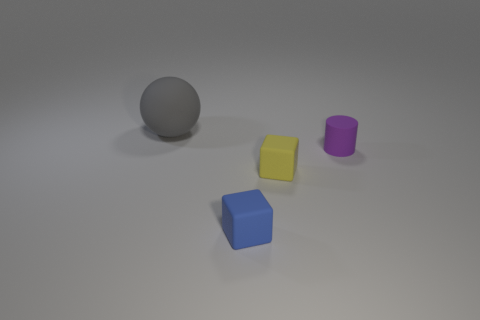What number of other things are there of the same size as the yellow block?
Ensure brevity in your answer.  2. How many things are either gray objects or purple objects?
Your response must be concise. 2. Is there anything else that is the same color as the large rubber sphere?
Keep it short and to the point. No. What is the shape of the tiny purple matte object that is right of the matte cube left of the yellow rubber object?
Your answer should be very brief. Cylinder. There is a thing that is behind the tiny yellow block and to the right of the small blue matte block; what shape is it?
Offer a very short reply. Cylinder. How many things are either tiny green metallic blocks or objects left of the tiny blue rubber thing?
Offer a terse response. 1. How many other small matte objects are the same shape as the yellow object?
Your answer should be compact. 1. There is a tiny thing right of the tiny cube right of the tiny blue rubber thing; what color is it?
Keep it short and to the point. Purple. Is the number of small purple rubber cylinders that are on the right side of the tiny purple matte cylinder the same as the number of cyan objects?
Offer a very short reply. Yes. Is there a gray matte cylinder that has the same size as the purple cylinder?
Make the answer very short. No. 